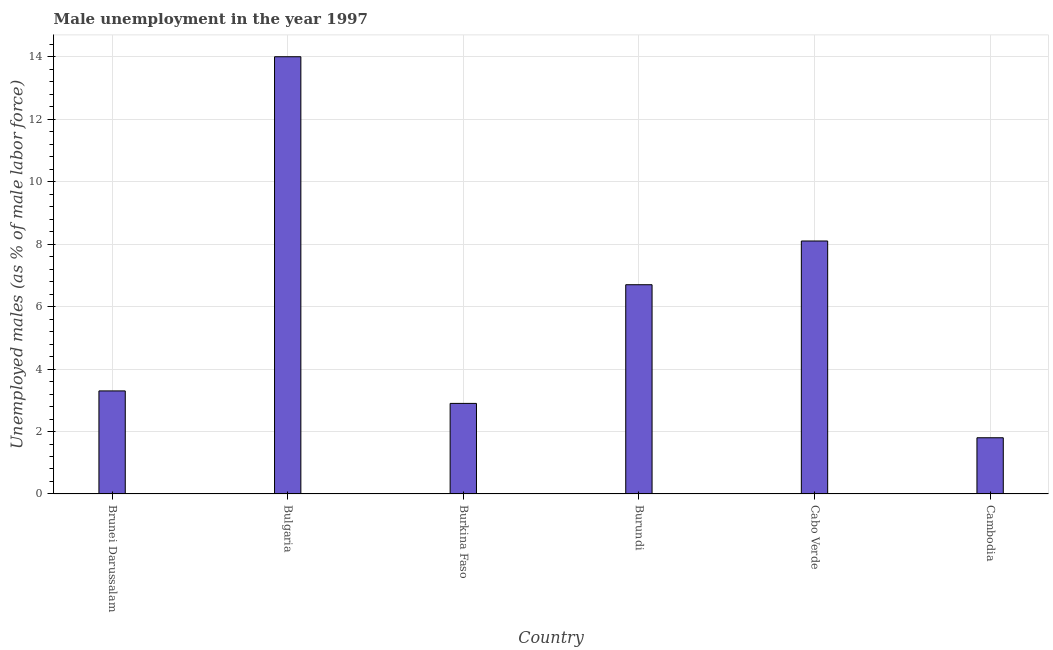Does the graph contain grids?
Give a very brief answer. Yes. What is the title of the graph?
Your answer should be very brief. Male unemployment in the year 1997. What is the label or title of the Y-axis?
Your answer should be very brief. Unemployed males (as % of male labor force). What is the unemployed males population in Cambodia?
Make the answer very short. 1.8. Across all countries, what is the minimum unemployed males population?
Provide a succinct answer. 1.8. In which country was the unemployed males population minimum?
Ensure brevity in your answer.  Cambodia. What is the sum of the unemployed males population?
Ensure brevity in your answer.  36.8. What is the average unemployed males population per country?
Provide a short and direct response. 6.13. What is the median unemployed males population?
Provide a short and direct response. 5. What is the ratio of the unemployed males population in Bulgaria to that in Burundi?
Your answer should be compact. 2.09. Is the unemployed males population in Bulgaria less than that in Cambodia?
Give a very brief answer. No. Is the difference between the unemployed males population in Brunei Darussalam and Burkina Faso greater than the difference between any two countries?
Make the answer very short. No. What is the difference between the highest and the second highest unemployed males population?
Your answer should be compact. 5.9. Is the sum of the unemployed males population in Brunei Darussalam and Burkina Faso greater than the maximum unemployed males population across all countries?
Your answer should be very brief. No. What is the difference between the highest and the lowest unemployed males population?
Offer a terse response. 12.2. In how many countries, is the unemployed males population greater than the average unemployed males population taken over all countries?
Offer a very short reply. 3. What is the Unemployed males (as % of male labor force) of Brunei Darussalam?
Offer a terse response. 3.3. What is the Unemployed males (as % of male labor force) in Bulgaria?
Your answer should be very brief. 14. What is the Unemployed males (as % of male labor force) of Burkina Faso?
Ensure brevity in your answer.  2.9. What is the Unemployed males (as % of male labor force) of Burundi?
Make the answer very short. 6.7. What is the Unemployed males (as % of male labor force) in Cabo Verde?
Your response must be concise. 8.1. What is the Unemployed males (as % of male labor force) of Cambodia?
Make the answer very short. 1.8. What is the difference between the Unemployed males (as % of male labor force) in Brunei Darussalam and Bulgaria?
Make the answer very short. -10.7. What is the difference between the Unemployed males (as % of male labor force) in Brunei Darussalam and Burkina Faso?
Ensure brevity in your answer.  0.4. What is the difference between the Unemployed males (as % of male labor force) in Brunei Darussalam and Burundi?
Provide a short and direct response. -3.4. What is the difference between the Unemployed males (as % of male labor force) in Brunei Darussalam and Cabo Verde?
Your answer should be compact. -4.8. What is the difference between the Unemployed males (as % of male labor force) in Brunei Darussalam and Cambodia?
Give a very brief answer. 1.5. What is the difference between the Unemployed males (as % of male labor force) in Bulgaria and Cambodia?
Provide a succinct answer. 12.2. What is the difference between the Unemployed males (as % of male labor force) in Burkina Faso and Cabo Verde?
Provide a succinct answer. -5.2. What is the difference between the Unemployed males (as % of male labor force) in Burundi and Cabo Verde?
Make the answer very short. -1.4. What is the difference between the Unemployed males (as % of male labor force) in Burundi and Cambodia?
Your answer should be very brief. 4.9. What is the difference between the Unemployed males (as % of male labor force) in Cabo Verde and Cambodia?
Your response must be concise. 6.3. What is the ratio of the Unemployed males (as % of male labor force) in Brunei Darussalam to that in Bulgaria?
Your response must be concise. 0.24. What is the ratio of the Unemployed males (as % of male labor force) in Brunei Darussalam to that in Burkina Faso?
Make the answer very short. 1.14. What is the ratio of the Unemployed males (as % of male labor force) in Brunei Darussalam to that in Burundi?
Give a very brief answer. 0.49. What is the ratio of the Unemployed males (as % of male labor force) in Brunei Darussalam to that in Cabo Verde?
Ensure brevity in your answer.  0.41. What is the ratio of the Unemployed males (as % of male labor force) in Brunei Darussalam to that in Cambodia?
Give a very brief answer. 1.83. What is the ratio of the Unemployed males (as % of male labor force) in Bulgaria to that in Burkina Faso?
Your response must be concise. 4.83. What is the ratio of the Unemployed males (as % of male labor force) in Bulgaria to that in Burundi?
Your response must be concise. 2.09. What is the ratio of the Unemployed males (as % of male labor force) in Bulgaria to that in Cabo Verde?
Offer a terse response. 1.73. What is the ratio of the Unemployed males (as % of male labor force) in Bulgaria to that in Cambodia?
Keep it short and to the point. 7.78. What is the ratio of the Unemployed males (as % of male labor force) in Burkina Faso to that in Burundi?
Make the answer very short. 0.43. What is the ratio of the Unemployed males (as % of male labor force) in Burkina Faso to that in Cabo Verde?
Your answer should be compact. 0.36. What is the ratio of the Unemployed males (as % of male labor force) in Burkina Faso to that in Cambodia?
Ensure brevity in your answer.  1.61. What is the ratio of the Unemployed males (as % of male labor force) in Burundi to that in Cabo Verde?
Offer a terse response. 0.83. What is the ratio of the Unemployed males (as % of male labor force) in Burundi to that in Cambodia?
Your response must be concise. 3.72. 